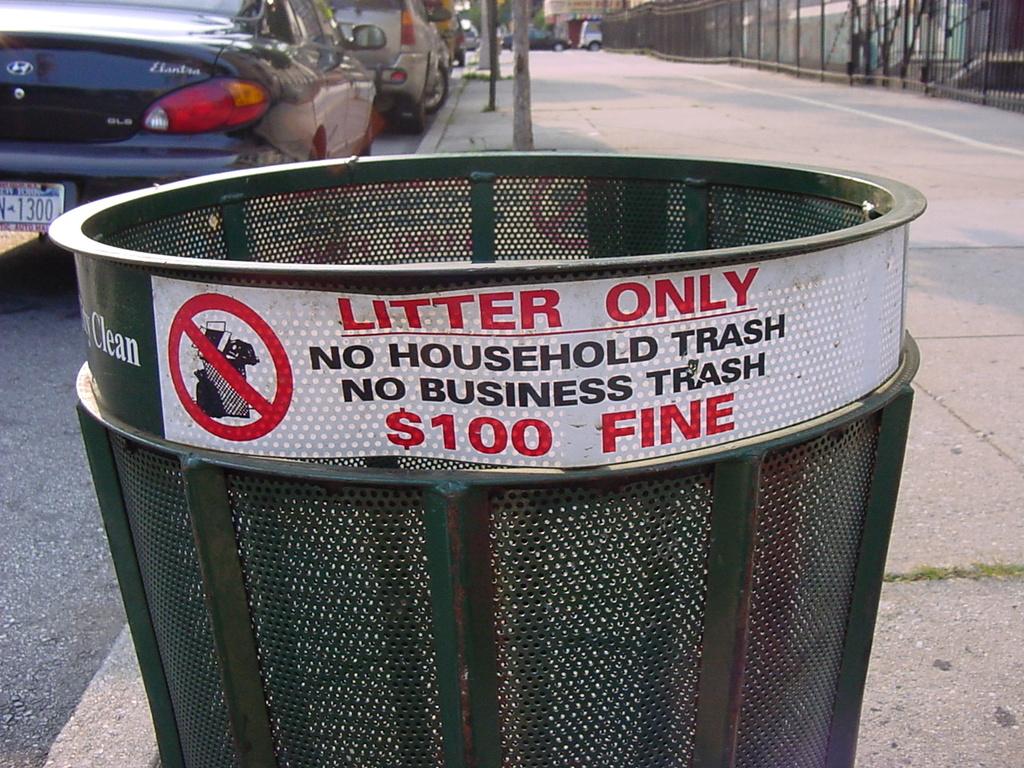How much is the fine for business or household trash?
Keep it short and to the point. $100. Can household trash go here?
Keep it short and to the point. No. 